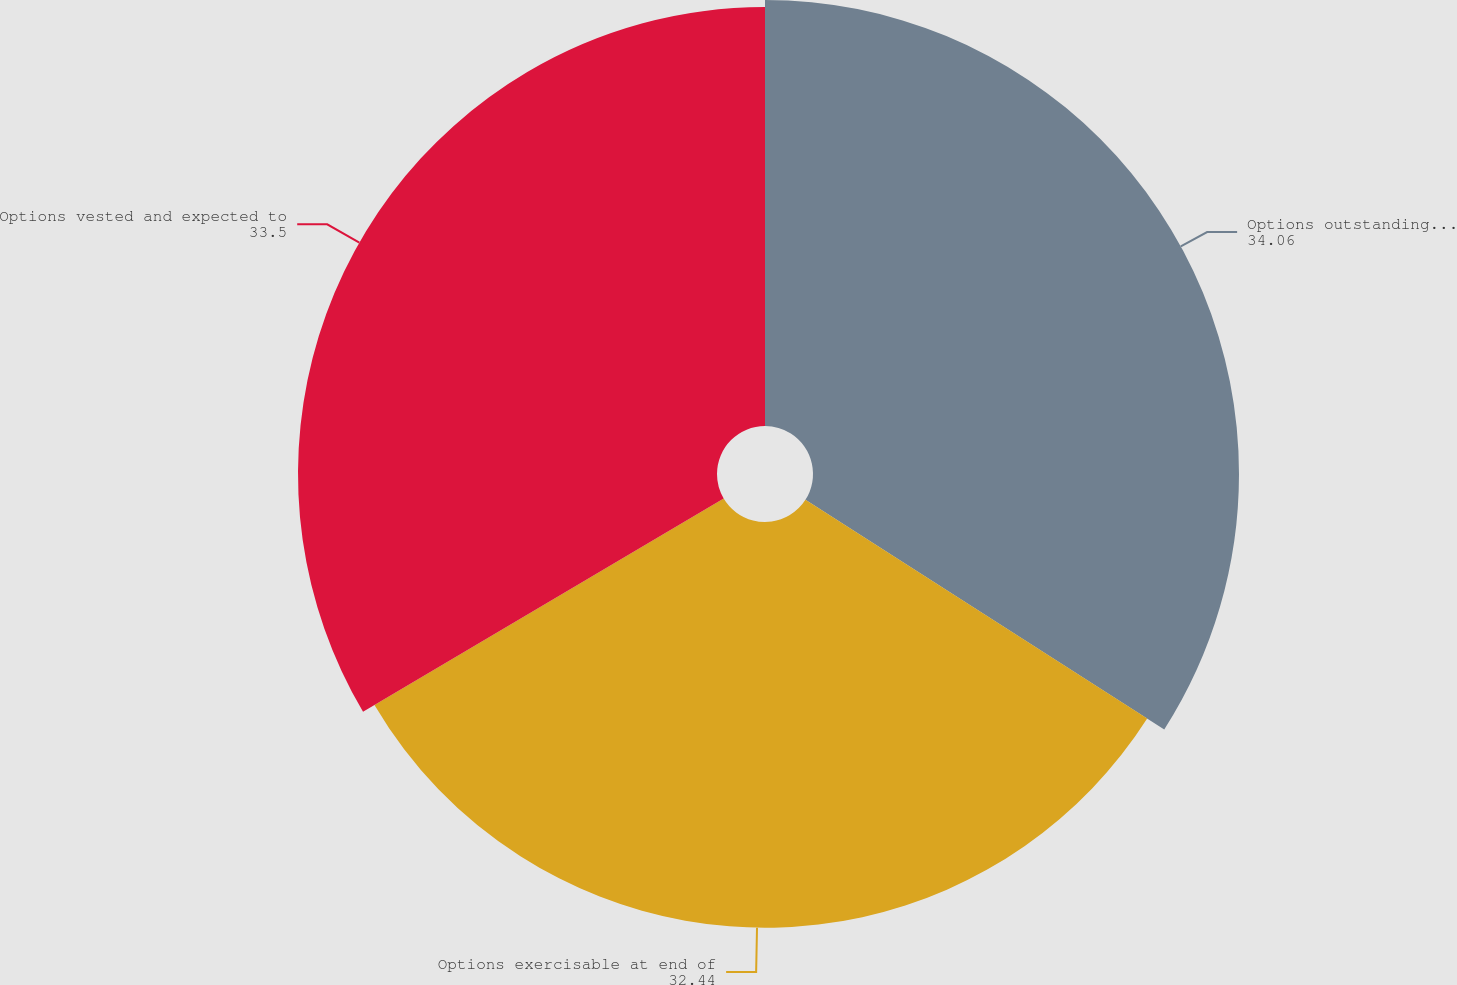Convert chart to OTSL. <chart><loc_0><loc_0><loc_500><loc_500><pie_chart><fcel>Options outstanding at end of<fcel>Options exercisable at end of<fcel>Options vested and expected to<nl><fcel>34.06%<fcel>32.44%<fcel>33.5%<nl></chart> 